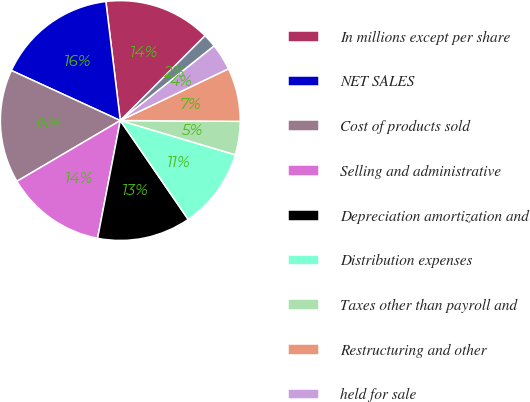Convert chart. <chart><loc_0><loc_0><loc_500><loc_500><pie_chart><fcel>In millions except per share<fcel>NET SALES<fcel>Cost of products sold<fcel>Selling and administrative<fcel>Depreciation amortization and<fcel>Distribution expenses<fcel>Taxes other than payroll and<fcel>Restructuring and other<fcel>held for sale<fcel>Reversals of reserves no<nl><fcel>14.41%<fcel>16.22%<fcel>15.31%<fcel>13.51%<fcel>12.61%<fcel>10.81%<fcel>4.5%<fcel>7.21%<fcel>3.6%<fcel>1.8%<nl></chart> 